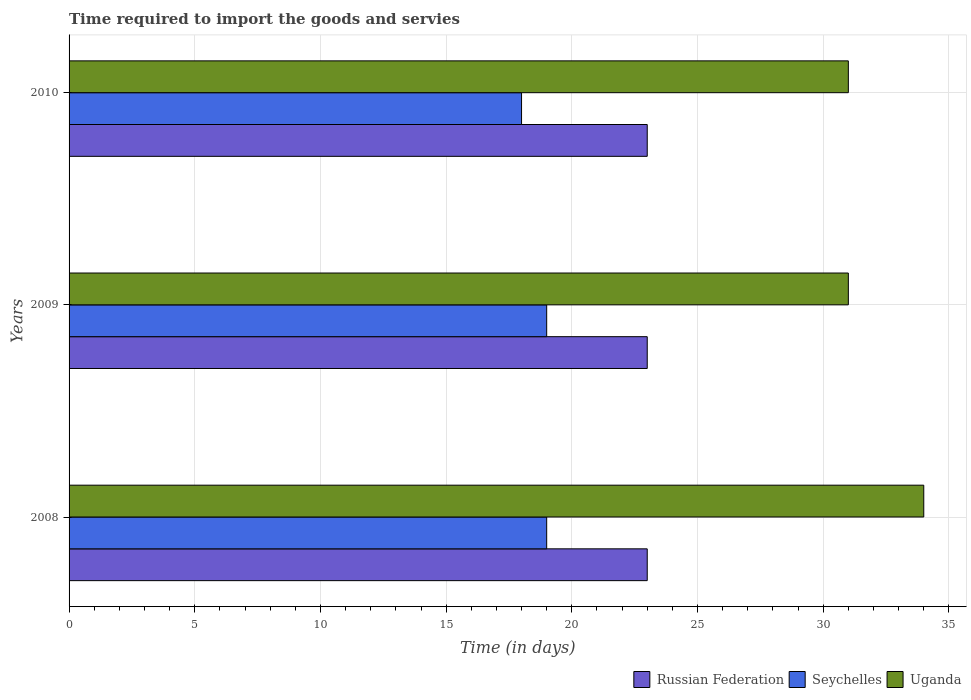How many groups of bars are there?
Ensure brevity in your answer.  3. Are the number of bars per tick equal to the number of legend labels?
Your answer should be very brief. Yes. How many bars are there on the 3rd tick from the top?
Give a very brief answer. 3. What is the number of days required to import the goods and services in Seychelles in 2008?
Offer a very short reply. 19. Across all years, what is the maximum number of days required to import the goods and services in Uganda?
Offer a very short reply. 34. Across all years, what is the minimum number of days required to import the goods and services in Uganda?
Keep it short and to the point. 31. In which year was the number of days required to import the goods and services in Russian Federation minimum?
Offer a terse response. 2008. What is the total number of days required to import the goods and services in Seychelles in the graph?
Make the answer very short. 56. What is the difference between the number of days required to import the goods and services in Seychelles in 2008 and that in 2010?
Provide a short and direct response. 1. What is the difference between the number of days required to import the goods and services in Seychelles in 2010 and the number of days required to import the goods and services in Uganda in 2009?
Keep it short and to the point. -13. What is the average number of days required to import the goods and services in Seychelles per year?
Keep it short and to the point. 18.67. In the year 2008, what is the difference between the number of days required to import the goods and services in Seychelles and number of days required to import the goods and services in Russian Federation?
Your answer should be compact. -4. In how many years, is the number of days required to import the goods and services in Russian Federation greater than 7 days?
Provide a short and direct response. 3. Is the difference between the number of days required to import the goods and services in Seychelles in 2009 and 2010 greater than the difference between the number of days required to import the goods and services in Russian Federation in 2009 and 2010?
Your answer should be very brief. Yes. What is the difference between the highest and the second highest number of days required to import the goods and services in Russian Federation?
Offer a very short reply. 0. What is the difference between the highest and the lowest number of days required to import the goods and services in Seychelles?
Your answer should be very brief. 1. Is the sum of the number of days required to import the goods and services in Russian Federation in 2008 and 2010 greater than the maximum number of days required to import the goods and services in Seychelles across all years?
Make the answer very short. Yes. What does the 3rd bar from the top in 2009 represents?
Offer a very short reply. Russian Federation. What does the 3rd bar from the bottom in 2008 represents?
Offer a very short reply. Uganda. How many bars are there?
Offer a terse response. 9. How many years are there in the graph?
Make the answer very short. 3. What is the difference between two consecutive major ticks on the X-axis?
Your answer should be compact. 5. Are the values on the major ticks of X-axis written in scientific E-notation?
Provide a succinct answer. No. Does the graph contain grids?
Keep it short and to the point. Yes. How many legend labels are there?
Ensure brevity in your answer.  3. How are the legend labels stacked?
Ensure brevity in your answer.  Horizontal. What is the title of the graph?
Give a very brief answer. Time required to import the goods and servies. What is the label or title of the X-axis?
Offer a terse response. Time (in days). What is the label or title of the Y-axis?
Offer a very short reply. Years. What is the Time (in days) of Uganda in 2008?
Your answer should be compact. 34. What is the Time (in days) in Uganda in 2009?
Make the answer very short. 31. What is the Time (in days) in Russian Federation in 2010?
Provide a succinct answer. 23. Across all years, what is the maximum Time (in days) of Seychelles?
Make the answer very short. 19. Across all years, what is the minimum Time (in days) in Russian Federation?
Offer a very short reply. 23. Across all years, what is the minimum Time (in days) of Seychelles?
Your answer should be very brief. 18. What is the total Time (in days) in Seychelles in the graph?
Provide a short and direct response. 56. What is the total Time (in days) in Uganda in the graph?
Provide a succinct answer. 96. What is the difference between the Time (in days) in Seychelles in 2008 and that in 2009?
Provide a succinct answer. 0. What is the difference between the Time (in days) in Russian Federation in 2008 and that in 2010?
Provide a succinct answer. 0. What is the difference between the Time (in days) in Uganda in 2008 and that in 2010?
Your response must be concise. 3. What is the difference between the Time (in days) in Russian Federation in 2009 and that in 2010?
Provide a short and direct response. 0. What is the difference between the Time (in days) in Seychelles in 2009 and that in 2010?
Make the answer very short. 1. What is the difference between the Time (in days) in Uganda in 2009 and that in 2010?
Give a very brief answer. 0. What is the difference between the Time (in days) in Russian Federation in 2008 and the Time (in days) in Seychelles in 2009?
Ensure brevity in your answer.  4. What is the difference between the Time (in days) of Russian Federation in 2008 and the Time (in days) of Uganda in 2009?
Make the answer very short. -8. What is the difference between the Time (in days) of Seychelles in 2008 and the Time (in days) of Uganda in 2009?
Provide a short and direct response. -12. What is the difference between the Time (in days) in Russian Federation in 2008 and the Time (in days) in Uganda in 2010?
Give a very brief answer. -8. What is the difference between the Time (in days) of Seychelles in 2008 and the Time (in days) of Uganda in 2010?
Keep it short and to the point. -12. What is the difference between the Time (in days) of Russian Federation in 2009 and the Time (in days) of Seychelles in 2010?
Your answer should be very brief. 5. What is the average Time (in days) in Seychelles per year?
Keep it short and to the point. 18.67. What is the average Time (in days) of Uganda per year?
Offer a very short reply. 32. In the year 2008, what is the difference between the Time (in days) of Russian Federation and Time (in days) of Seychelles?
Your response must be concise. 4. In the year 2008, what is the difference between the Time (in days) in Russian Federation and Time (in days) in Uganda?
Provide a succinct answer. -11. In the year 2009, what is the difference between the Time (in days) in Seychelles and Time (in days) in Uganda?
Your response must be concise. -12. In the year 2010, what is the difference between the Time (in days) in Russian Federation and Time (in days) in Seychelles?
Keep it short and to the point. 5. In the year 2010, what is the difference between the Time (in days) of Russian Federation and Time (in days) of Uganda?
Your answer should be compact. -8. What is the ratio of the Time (in days) of Uganda in 2008 to that in 2009?
Offer a very short reply. 1.1. What is the ratio of the Time (in days) in Seychelles in 2008 to that in 2010?
Provide a short and direct response. 1.06. What is the ratio of the Time (in days) in Uganda in 2008 to that in 2010?
Offer a terse response. 1.1. What is the ratio of the Time (in days) in Seychelles in 2009 to that in 2010?
Provide a succinct answer. 1.06. What is the ratio of the Time (in days) of Uganda in 2009 to that in 2010?
Provide a succinct answer. 1. What is the difference between the highest and the second highest Time (in days) of Uganda?
Keep it short and to the point. 3. What is the difference between the highest and the lowest Time (in days) in Russian Federation?
Your response must be concise. 0. 